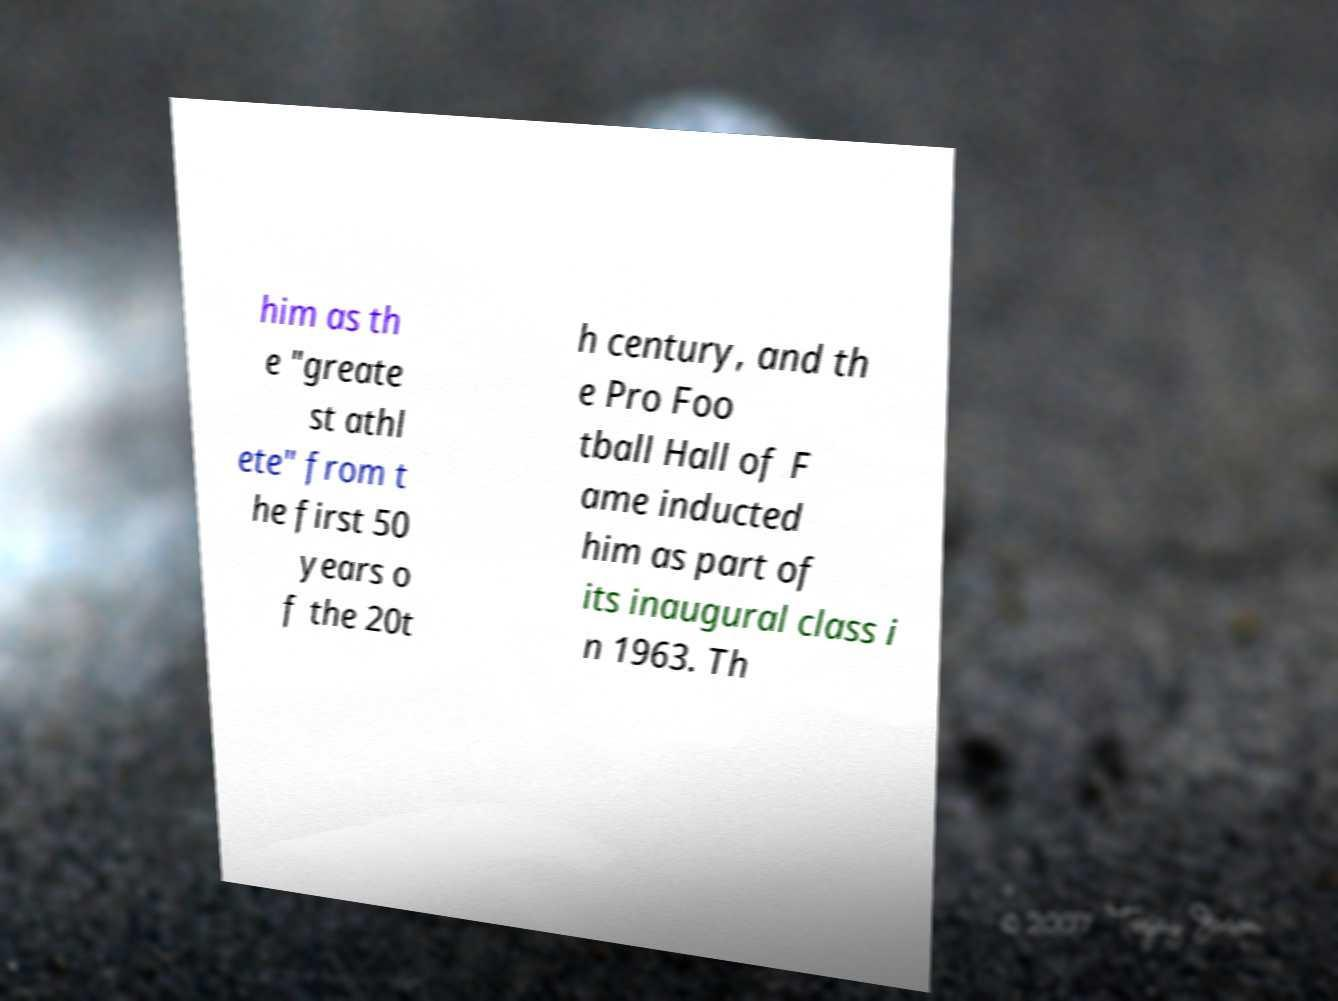For documentation purposes, I need the text within this image transcribed. Could you provide that? him as th e "greate st athl ete" from t he first 50 years o f the 20t h century, and th e Pro Foo tball Hall of F ame inducted him as part of its inaugural class i n 1963. Th 